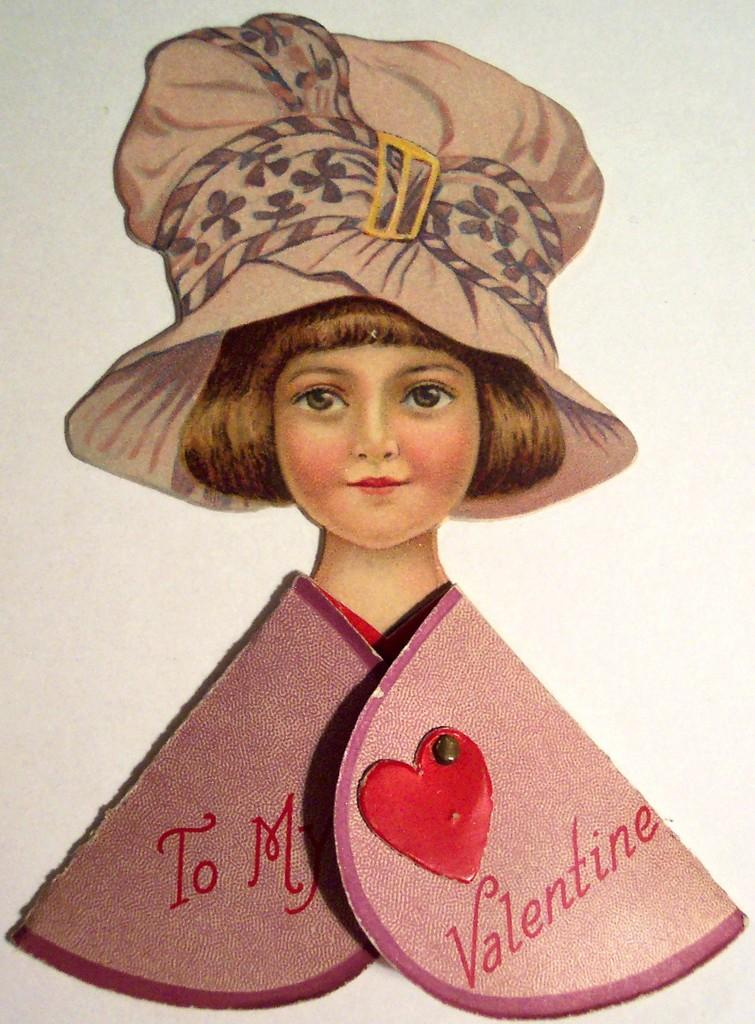Who is present in the image? There is a person in the image. What is the person wearing on their head? The person is wearing a cap. What type of objects with text can be seen in the image? There are cardboard pieces with text in the image. What symbol is visible in the image? There is a heart symbol in the image. How many grapes are being used to create the thing in the image? There are no grapes present in the image, and no "thing" is being created. 